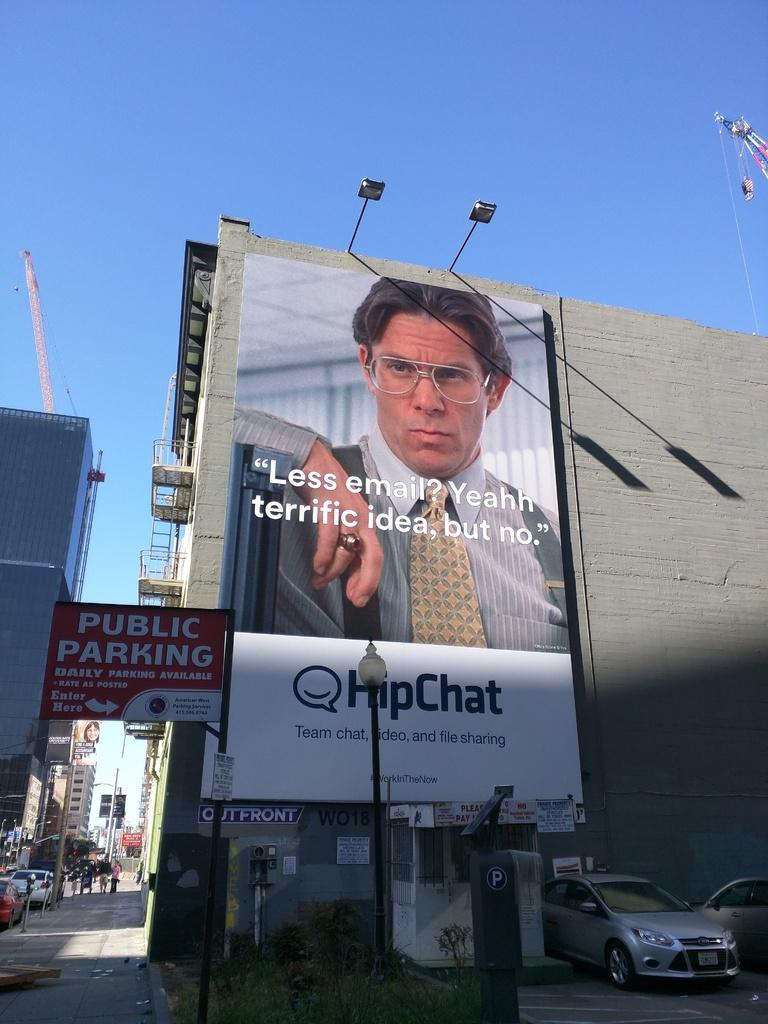<image>
Offer a succinct explanation of the picture presented. A large billboard for HipChat on a city building. 